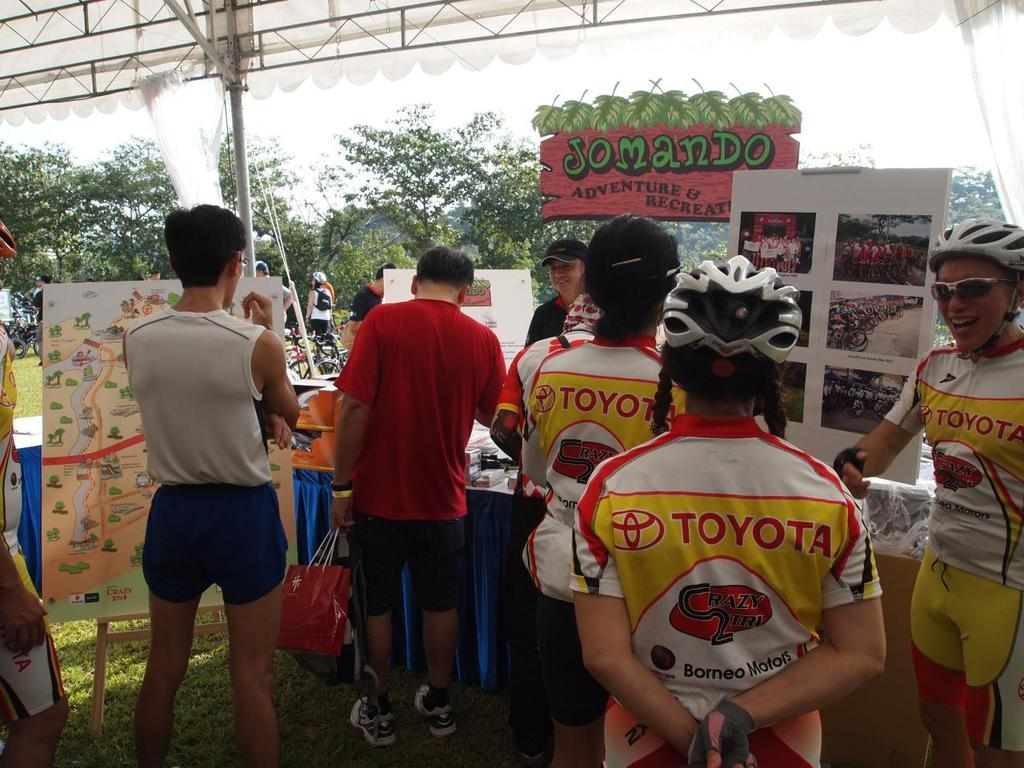<image>
Render a clear and concise summary of the photo. cyclists wearing Toyota jersey are waiting in line 